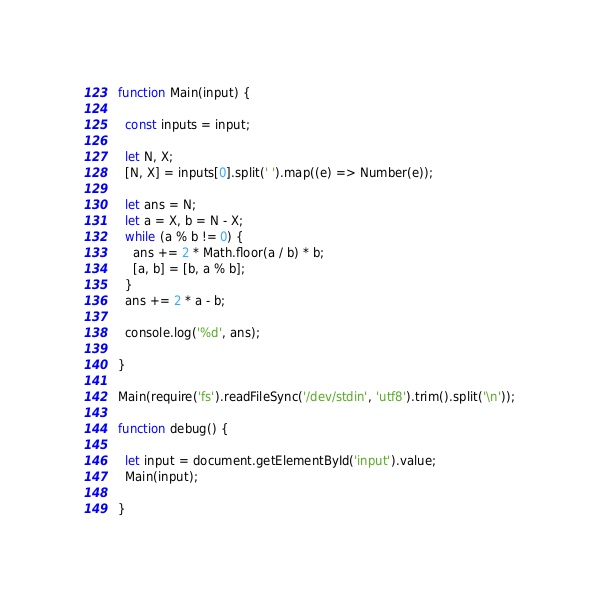Convert code to text. <code><loc_0><loc_0><loc_500><loc_500><_JavaScript_>function Main(input) {

  const inputs = input;

  let N, X;
  [N, X] = inputs[0].split(' ').map((e) => Number(e));

  let ans = N;
  let a = X, b = N - X;
  while (a % b != 0) {
    ans += 2 * Math.floor(a / b) * b;
    [a, b] = [b, a % b];
  }
  ans += 2 * a - b;

  console.log('%d', ans);

}

Main(require('fs').readFileSync('/dev/stdin', 'utf8').trim().split('\n'));

function debug() {

  let input = document.getElementById('input').value;
  Main(input);

}
</code> 